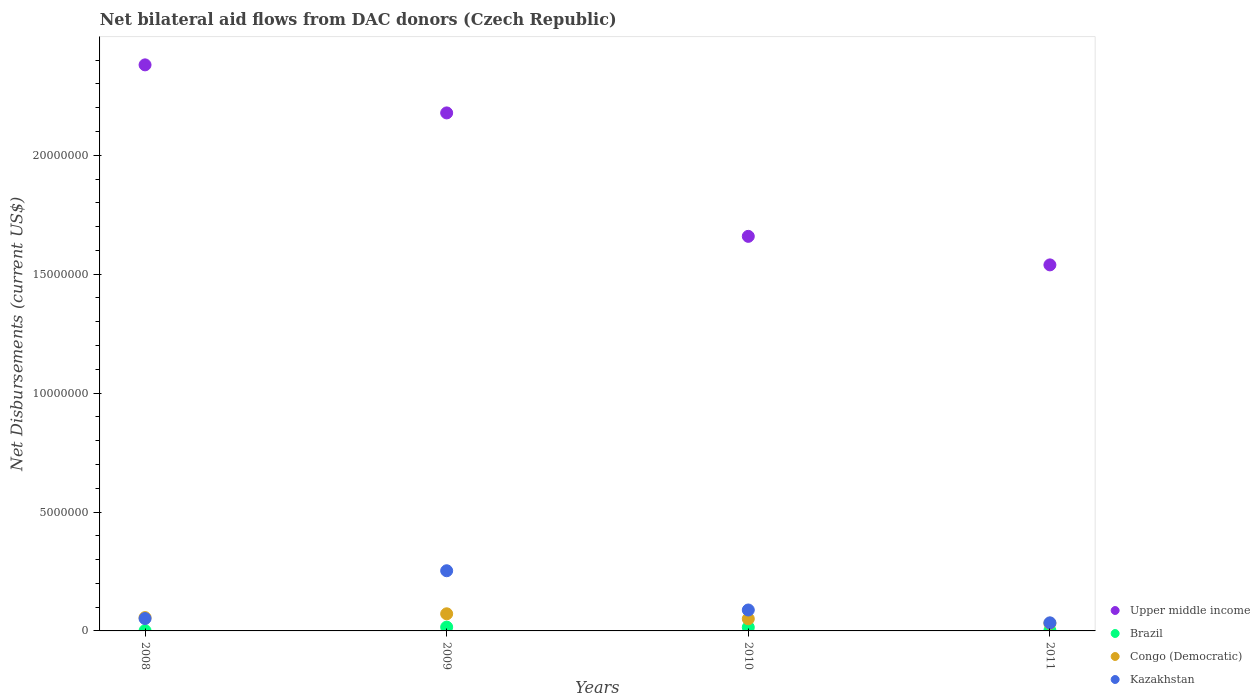What is the net bilateral aid flows in Brazil in 2009?
Provide a succinct answer. 1.60e+05. Across all years, what is the maximum net bilateral aid flows in Upper middle income?
Your answer should be compact. 2.38e+07. In which year was the net bilateral aid flows in Upper middle income maximum?
Your answer should be compact. 2008. In which year was the net bilateral aid flows in Kazakhstan minimum?
Offer a very short reply. 2011. What is the total net bilateral aid flows in Brazil in the graph?
Give a very brief answer. 3.40e+05. What is the difference between the net bilateral aid flows in Kazakhstan in 2008 and that in 2011?
Your response must be concise. 1.80e+05. What is the difference between the net bilateral aid flows in Upper middle income in 2009 and the net bilateral aid flows in Congo (Democratic) in 2008?
Offer a terse response. 2.12e+07. What is the average net bilateral aid flows in Kazakhstan per year?
Offer a very short reply. 1.07e+06. In the year 2010, what is the difference between the net bilateral aid flows in Brazil and net bilateral aid flows in Upper middle income?
Ensure brevity in your answer.  -1.64e+07. In how many years, is the net bilateral aid flows in Brazil greater than 6000000 US$?
Keep it short and to the point. 0. What is the ratio of the net bilateral aid flows in Kazakhstan in 2009 to that in 2011?
Provide a short and direct response. 7.44. Is the difference between the net bilateral aid flows in Brazil in 2008 and 2010 greater than the difference between the net bilateral aid flows in Upper middle income in 2008 and 2010?
Keep it short and to the point. No. What is the difference between the highest and the second highest net bilateral aid flows in Upper middle income?
Give a very brief answer. 2.02e+06. What is the difference between the highest and the lowest net bilateral aid flows in Upper middle income?
Provide a succinct answer. 8.41e+06. Is the sum of the net bilateral aid flows in Brazil in 2009 and 2010 greater than the maximum net bilateral aid flows in Upper middle income across all years?
Your response must be concise. No. Is it the case that in every year, the sum of the net bilateral aid flows in Congo (Democratic) and net bilateral aid flows in Upper middle income  is greater than the net bilateral aid flows in Brazil?
Keep it short and to the point. Yes. Does the net bilateral aid flows in Kazakhstan monotonically increase over the years?
Offer a terse response. No. Is the net bilateral aid flows in Upper middle income strictly less than the net bilateral aid flows in Brazil over the years?
Provide a short and direct response. No. How many years are there in the graph?
Your response must be concise. 4. Does the graph contain any zero values?
Your answer should be compact. No. Does the graph contain grids?
Provide a short and direct response. No. How are the legend labels stacked?
Your answer should be very brief. Vertical. What is the title of the graph?
Give a very brief answer. Net bilateral aid flows from DAC donors (Czech Republic). Does "Korea (Democratic)" appear as one of the legend labels in the graph?
Your answer should be very brief. No. What is the label or title of the X-axis?
Your answer should be very brief. Years. What is the label or title of the Y-axis?
Offer a very short reply. Net Disbursements (current US$). What is the Net Disbursements (current US$) of Upper middle income in 2008?
Your response must be concise. 2.38e+07. What is the Net Disbursements (current US$) in Congo (Democratic) in 2008?
Your answer should be very brief. 5.60e+05. What is the Net Disbursements (current US$) of Kazakhstan in 2008?
Offer a very short reply. 5.20e+05. What is the Net Disbursements (current US$) in Upper middle income in 2009?
Keep it short and to the point. 2.18e+07. What is the Net Disbursements (current US$) of Brazil in 2009?
Offer a very short reply. 1.60e+05. What is the Net Disbursements (current US$) in Congo (Democratic) in 2009?
Make the answer very short. 7.20e+05. What is the Net Disbursements (current US$) of Kazakhstan in 2009?
Your answer should be compact. 2.53e+06. What is the Net Disbursements (current US$) in Upper middle income in 2010?
Make the answer very short. 1.66e+07. What is the Net Disbursements (current US$) of Brazil in 2010?
Your response must be concise. 1.50e+05. What is the Net Disbursements (current US$) of Congo (Democratic) in 2010?
Your response must be concise. 5.10e+05. What is the Net Disbursements (current US$) in Kazakhstan in 2010?
Your answer should be very brief. 8.80e+05. What is the Net Disbursements (current US$) in Upper middle income in 2011?
Your answer should be compact. 1.54e+07. What is the Net Disbursements (current US$) of Congo (Democratic) in 2011?
Provide a short and direct response. 3.20e+05. Across all years, what is the maximum Net Disbursements (current US$) in Upper middle income?
Your answer should be compact. 2.38e+07. Across all years, what is the maximum Net Disbursements (current US$) of Brazil?
Keep it short and to the point. 1.60e+05. Across all years, what is the maximum Net Disbursements (current US$) in Congo (Democratic)?
Your answer should be very brief. 7.20e+05. Across all years, what is the maximum Net Disbursements (current US$) of Kazakhstan?
Make the answer very short. 2.53e+06. Across all years, what is the minimum Net Disbursements (current US$) in Upper middle income?
Give a very brief answer. 1.54e+07. Across all years, what is the minimum Net Disbursements (current US$) in Kazakhstan?
Provide a short and direct response. 3.40e+05. What is the total Net Disbursements (current US$) of Upper middle income in the graph?
Your answer should be compact. 7.76e+07. What is the total Net Disbursements (current US$) of Brazil in the graph?
Give a very brief answer. 3.40e+05. What is the total Net Disbursements (current US$) in Congo (Democratic) in the graph?
Offer a very short reply. 2.11e+06. What is the total Net Disbursements (current US$) of Kazakhstan in the graph?
Your response must be concise. 4.27e+06. What is the difference between the Net Disbursements (current US$) in Upper middle income in 2008 and that in 2009?
Make the answer very short. 2.02e+06. What is the difference between the Net Disbursements (current US$) in Brazil in 2008 and that in 2009?
Offer a terse response. -1.50e+05. What is the difference between the Net Disbursements (current US$) of Kazakhstan in 2008 and that in 2009?
Your response must be concise. -2.01e+06. What is the difference between the Net Disbursements (current US$) of Upper middle income in 2008 and that in 2010?
Your answer should be very brief. 7.21e+06. What is the difference between the Net Disbursements (current US$) of Kazakhstan in 2008 and that in 2010?
Your answer should be compact. -3.60e+05. What is the difference between the Net Disbursements (current US$) of Upper middle income in 2008 and that in 2011?
Your answer should be very brief. 8.41e+06. What is the difference between the Net Disbursements (current US$) in Congo (Democratic) in 2008 and that in 2011?
Provide a short and direct response. 2.40e+05. What is the difference between the Net Disbursements (current US$) of Kazakhstan in 2008 and that in 2011?
Provide a short and direct response. 1.80e+05. What is the difference between the Net Disbursements (current US$) in Upper middle income in 2009 and that in 2010?
Provide a short and direct response. 5.19e+06. What is the difference between the Net Disbursements (current US$) in Brazil in 2009 and that in 2010?
Your response must be concise. 10000. What is the difference between the Net Disbursements (current US$) in Kazakhstan in 2009 and that in 2010?
Offer a terse response. 1.65e+06. What is the difference between the Net Disbursements (current US$) in Upper middle income in 2009 and that in 2011?
Provide a succinct answer. 6.39e+06. What is the difference between the Net Disbursements (current US$) in Kazakhstan in 2009 and that in 2011?
Your response must be concise. 2.19e+06. What is the difference between the Net Disbursements (current US$) of Upper middle income in 2010 and that in 2011?
Ensure brevity in your answer.  1.20e+06. What is the difference between the Net Disbursements (current US$) in Brazil in 2010 and that in 2011?
Give a very brief answer. 1.30e+05. What is the difference between the Net Disbursements (current US$) of Kazakhstan in 2010 and that in 2011?
Offer a very short reply. 5.40e+05. What is the difference between the Net Disbursements (current US$) in Upper middle income in 2008 and the Net Disbursements (current US$) in Brazil in 2009?
Provide a succinct answer. 2.36e+07. What is the difference between the Net Disbursements (current US$) in Upper middle income in 2008 and the Net Disbursements (current US$) in Congo (Democratic) in 2009?
Offer a very short reply. 2.31e+07. What is the difference between the Net Disbursements (current US$) in Upper middle income in 2008 and the Net Disbursements (current US$) in Kazakhstan in 2009?
Ensure brevity in your answer.  2.13e+07. What is the difference between the Net Disbursements (current US$) in Brazil in 2008 and the Net Disbursements (current US$) in Congo (Democratic) in 2009?
Ensure brevity in your answer.  -7.10e+05. What is the difference between the Net Disbursements (current US$) in Brazil in 2008 and the Net Disbursements (current US$) in Kazakhstan in 2009?
Offer a terse response. -2.52e+06. What is the difference between the Net Disbursements (current US$) in Congo (Democratic) in 2008 and the Net Disbursements (current US$) in Kazakhstan in 2009?
Your response must be concise. -1.97e+06. What is the difference between the Net Disbursements (current US$) in Upper middle income in 2008 and the Net Disbursements (current US$) in Brazil in 2010?
Provide a short and direct response. 2.36e+07. What is the difference between the Net Disbursements (current US$) of Upper middle income in 2008 and the Net Disbursements (current US$) of Congo (Democratic) in 2010?
Your answer should be very brief. 2.33e+07. What is the difference between the Net Disbursements (current US$) of Upper middle income in 2008 and the Net Disbursements (current US$) of Kazakhstan in 2010?
Provide a succinct answer. 2.29e+07. What is the difference between the Net Disbursements (current US$) of Brazil in 2008 and the Net Disbursements (current US$) of Congo (Democratic) in 2010?
Your answer should be compact. -5.00e+05. What is the difference between the Net Disbursements (current US$) of Brazil in 2008 and the Net Disbursements (current US$) of Kazakhstan in 2010?
Make the answer very short. -8.70e+05. What is the difference between the Net Disbursements (current US$) of Congo (Democratic) in 2008 and the Net Disbursements (current US$) of Kazakhstan in 2010?
Provide a short and direct response. -3.20e+05. What is the difference between the Net Disbursements (current US$) of Upper middle income in 2008 and the Net Disbursements (current US$) of Brazil in 2011?
Keep it short and to the point. 2.38e+07. What is the difference between the Net Disbursements (current US$) in Upper middle income in 2008 and the Net Disbursements (current US$) in Congo (Democratic) in 2011?
Make the answer very short. 2.35e+07. What is the difference between the Net Disbursements (current US$) of Upper middle income in 2008 and the Net Disbursements (current US$) of Kazakhstan in 2011?
Provide a succinct answer. 2.35e+07. What is the difference between the Net Disbursements (current US$) of Brazil in 2008 and the Net Disbursements (current US$) of Congo (Democratic) in 2011?
Give a very brief answer. -3.10e+05. What is the difference between the Net Disbursements (current US$) in Brazil in 2008 and the Net Disbursements (current US$) in Kazakhstan in 2011?
Ensure brevity in your answer.  -3.30e+05. What is the difference between the Net Disbursements (current US$) in Congo (Democratic) in 2008 and the Net Disbursements (current US$) in Kazakhstan in 2011?
Provide a short and direct response. 2.20e+05. What is the difference between the Net Disbursements (current US$) in Upper middle income in 2009 and the Net Disbursements (current US$) in Brazil in 2010?
Your response must be concise. 2.16e+07. What is the difference between the Net Disbursements (current US$) in Upper middle income in 2009 and the Net Disbursements (current US$) in Congo (Democratic) in 2010?
Make the answer very short. 2.13e+07. What is the difference between the Net Disbursements (current US$) of Upper middle income in 2009 and the Net Disbursements (current US$) of Kazakhstan in 2010?
Ensure brevity in your answer.  2.09e+07. What is the difference between the Net Disbursements (current US$) of Brazil in 2009 and the Net Disbursements (current US$) of Congo (Democratic) in 2010?
Make the answer very short. -3.50e+05. What is the difference between the Net Disbursements (current US$) of Brazil in 2009 and the Net Disbursements (current US$) of Kazakhstan in 2010?
Your response must be concise. -7.20e+05. What is the difference between the Net Disbursements (current US$) of Congo (Democratic) in 2009 and the Net Disbursements (current US$) of Kazakhstan in 2010?
Ensure brevity in your answer.  -1.60e+05. What is the difference between the Net Disbursements (current US$) in Upper middle income in 2009 and the Net Disbursements (current US$) in Brazil in 2011?
Offer a very short reply. 2.18e+07. What is the difference between the Net Disbursements (current US$) of Upper middle income in 2009 and the Net Disbursements (current US$) of Congo (Democratic) in 2011?
Make the answer very short. 2.15e+07. What is the difference between the Net Disbursements (current US$) in Upper middle income in 2009 and the Net Disbursements (current US$) in Kazakhstan in 2011?
Make the answer very short. 2.14e+07. What is the difference between the Net Disbursements (current US$) in Brazil in 2009 and the Net Disbursements (current US$) in Congo (Democratic) in 2011?
Make the answer very short. -1.60e+05. What is the difference between the Net Disbursements (current US$) of Upper middle income in 2010 and the Net Disbursements (current US$) of Brazil in 2011?
Provide a short and direct response. 1.66e+07. What is the difference between the Net Disbursements (current US$) in Upper middle income in 2010 and the Net Disbursements (current US$) in Congo (Democratic) in 2011?
Keep it short and to the point. 1.63e+07. What is the difference between the Net Disbursements (current US$) in Upper middle income in 2010 and the Net Disbursements (current US$) in Kazakhstan in 2011?
Your answer should be compact. 1.62e+07. What is the difference between the Net Disbursements (current US$) of Brazil in 2010 and the Net Disbursements (current US$) of Congo (Democratic) in 2011?
Provide a short and direct response. -1.70e+05. What is the difference between the Net Disbursements (current US$) in Brazil in 2010 and the Net Disbursements (current US$) in Kazakhstan in 2011?
Provide a succinct answer. -1.90e+05. What is the average Net Disbursements (current US$) of Upper middle income per year?
Ensure brevity in your answer.  1.94e+07. What is the average Net Disbursements (current US$) in Brazil per year?
Your answer should be compact. 8.50e+04. What is the average Net Disbursements (current US$) in Congo (Democratic) per year?
Give a very brief answer. 5.28e+05. What is the average Net Disbursements (current US$) of Kazakhstan per year?
Provide a short and direct response. 1.07e+06. In the year 2008, what is the difference between the Net Disbursements (current US$) of Upper middle income and Net Disbursements (current US$) of Brazil?
Your answer should be compact. 2.38e+07. In the year 2008, what is the difference between the Net Disbursements (current US$) of Upper middle income and Net Disbursements (current US$) of Congo (Democratic)?
Your answer should be very brief. 2.32e+07. In the year 2008, what is the difference between the Net Disbursements (current US$) of Upper middle income and Net Disbursements (current US$) of Kazakhstan?
Your answer should be compact. 2.33e+07. In the year 2008, what is the difference between the Net Disbursements (current US$) of Brazil and Net Disbursements (current US$) of Congo (Democratic)?
Your answer should be very brief. -5.50e+05. In the year 2008, what is the difference between the Net Disbursements (current US$) of Brazil and Net Disbursements (current US$) of Kazakhstan?
Your answer should be compact. -5.10e+05. In the year 2009, what is the difference between the Net Disbursements (current US$) in Upper middle income and Net Disbursements (current US$) in Brazil?
Your answer should be compact. 2.16e+07. In the year 2009, what is the difference between the Net Disbursements (current US$) of Upper middle income and Net Disbursements (current US$) of Congo (Democratic)?
Give a very brief answer. 2.11e+07. In the year 2009, what is the difference between the Net Disbursements (current US$) in Upper middle income and Net Disbursements (current US$) in Kazakhstan?
Provide a succinct answer. 1.92e+07. In the year 2009, what is the difference between the Net Disbursements (current US$) in Brazil and Net Disbursements (current US$) in Congo (Democratic)?
Keep it short and to the point. -5.60e+05. In the year 2009, what is the difference between the Net Disbursements (current US$) in Brazil and Net Disbursements (current US$) in Kazakhstan?
Offer a very short reply. -2.37e+06. In the year 2009, what is the difference between the Net Disbursements (current US$) of Congo (Democratic) and Net Disbursements (current US$) of Kazakhstan?
Provide a short and direct response. -1.81e+06. In the year 2010, what is the difference between the Net Disbursements (current US$) of Upper middle income and Net Disbursements (current US$) of Brazil?
Give a very brief answer. 1.64e+07. In the year 2010, what is the difference between the Net Disbursements (current US$) of Upper middle income and Net Disbursements (current US$) of Congo (Democratic)?
Offer a very short reply. 1.61e+07. In the year 2010, what is the difference between the Net Disbursements (current US$) in Upper middle income and Net Disbursements (current US$) in Kazakhstan?
Ensure brevity in your answer.  1.57e+07. In the year 2010, what is the difference between the Net Disbursements (current US$) of Brazil and Net Disbursements (current US$) of Congo (Democratic)?
Your answer should be very brief. -3.60e+05. In the year 2010, what is the difference between the Net Disbursements (current US$) in Brazil and Net Disbursements (current US$) in Kazakhstan?
Offer a terse response. -7.30e+05. In the year 2010, what is the difference between the Net Disbursements (current US$) in Congo (Democratic) and Net Disbursements (current US$) in Kazakhstan?
Provide a succinct answer. -3.70e+05. In the year 2011, what is the difference between the Net Disbursements (current US$) in Upper middle income and Net Disbursements (current US$) in Brazil?
Provide a succinct answer. 1.54e+07. In the year 2011, what is the difference between the Net Disbursements (current US$) of Upper middle income and Net Disbursements (current US$) of Congo (Democratic)?
Offer a terse response. 1.51e+07. In the year 2011, what is the difference between the Net Disbursements (current US$) in Upper middle income and Net Disbursements (current US$) in Kazakhstan?
Make the answer very short. 1.50e+07. In the year 2011, what is the difference between the Net Disbursements (current US$) in Brazil and Net Disbursements (current US$) in Kazakhstan?
Ensure brevity in your answer.  -3.20e+05. In the year 2011, what is the difference between the Net Disbursements (current US$) of Congo (Democratic) and Net Disbursements (current US$) of Kazakhstan?
Your answer should be compact. -2.00e+04. What is the ratio of the Net Disbursements (current US$) of Upper middle income in 2008 to that in 2009?
Offer a very short reply. 1.09. What is the ratio of the Net Disbursements (current US$) in Brazil in 2008 to that in 2009?
Give a very brief answer. 0.06. What is the ratio of the Net Disbursements (current US$) in Congo (Democratic) in 2008 to that in 2009?
Ensure brevity in your answer.  0.78. What is the ratio of the Net Disbursements (current US$) of Kazakhstan in 2008 to that in 2009?
Make the answer very short. 0.21. What is the ratio of the Net Disbursements (current US$) in Upper middle income in 2008 to that in 2010?
Your answer should be compact. 1.43. What is the ratio of the Net Disbursements (current US$) in Brazil in 2008 to that in 2010?
Offer a terse response. 0.07. What is the ratio of the Net Disbursements (current US$) of Congo (Democratic) in 2008 to that in 2010?
Offer a very short reply. 1.1. What is the ratio of the Net Disbursements (current US$) in Kazakhstan in 2008 to that in 2010?
Offer a very short reply. 0.59. What is the ratio of the Net Disbursements (current US$) of Upper middle income in 2008 to that in 2011?
Give a very brief answer. 1.55. What is the ratio of the Net Disbursements (current US$) of Brazil in 2008 to that in 2011?
Your answer should be very brief. 0.5. What is the ratio of the Net Disbursements (current US$) of Kazakhstan in 2008 to that in 2011?
Your answer should be very brief. 1.53. What is the ratio of the Net Disbursements (current US$) in Upper middle income in 2009 to that in 2010?
Your response must be concise. 1.31. What is the ratio of the Net Disbursements (current US$) of Brazil in 2009 to that in 2010?
Your answer should be very brief. 1.07. What is the ratio of the Net Disbursements (current US$) in Congo (Democratic) in 2009 to that in 2010?
Your response must be concise. 1.41. What is the ratio of the Net Disbursements (current US$) in Kazakhstan in 2009 to that in 2010?
Offer a very short reply. 2.88. What is the ratio of the Net Disbursements (current US$) of Upper middle income in 2009 to that in 2011?
Give a very brief answer. 1.42. What is the ratio of the Net Disbursements (current US$) in Congo (Democratic) in 2009 to that in 2011?
Your answer should be very brief. 2.25. What is the ratio of the Net Disbursements (current US$) of Kazakhstan in 2009 to that in 2011?
Provide a succinct answer. 7.44. What is the ratio of the Net Disbursements (current US$) of Upper middle income in 2010 to that in 2011?
Ensure brevity in your answer.  1.08. What is the ratio of the Net Disbursements (current US$) in Congo (Democratic) in 2010 to that in 2011?
Give a very brief answer. 1.59. What is the ratio of the Net Disbursements (current US$) in Kazakhstan in 2010 to that in 2011?
Offer a very short reply. 2.59. What is the difference between the highest and the second highest Net Disbursements (current US$) in Upper middle income?
Your answer should be compact. 2.02e+06. What is the difference between the highest and the second highest Net Disbursements (current US$) of Congo (Democratic)?
Your answer should be compact. 1.60e+05. What is the difference between the highest and the second highest Net Disbursements (current US$) of Kazakhstan?
Your answer should be very brief. 1.65e+06. What is the difference between the highest and the lowest Net Disbursements (current US$) in Upper middle income?
Give a very brief answer. 8.41e+06. What is the difference between the highest and the lowest Net Disbursements (current US$) of Congo (Democratic)?
Make the answer very short. 4.00e+05. What is the difference between the highest and the lowest Net Disbursements (current US$) in Kazakhstan?
Your answer should be compact. 2.19e+06. 